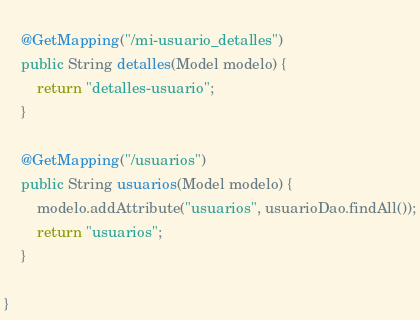Convert code to text. <code><loc_0><loc_0><loc_500><loc_500><_Java_>	
	@GetMapping("/mi-usuario_detalles")
	public String detalles(Model modelo) {
		return "detalles-usuario";
	}
	
	@GetMapping("/usuarios")
	public String usuarios(Model modelo) {
		modelo.addAttribute("usuarios", usuarioDao.findAll());
		return "usuarios";
	}
	
}
</code> 